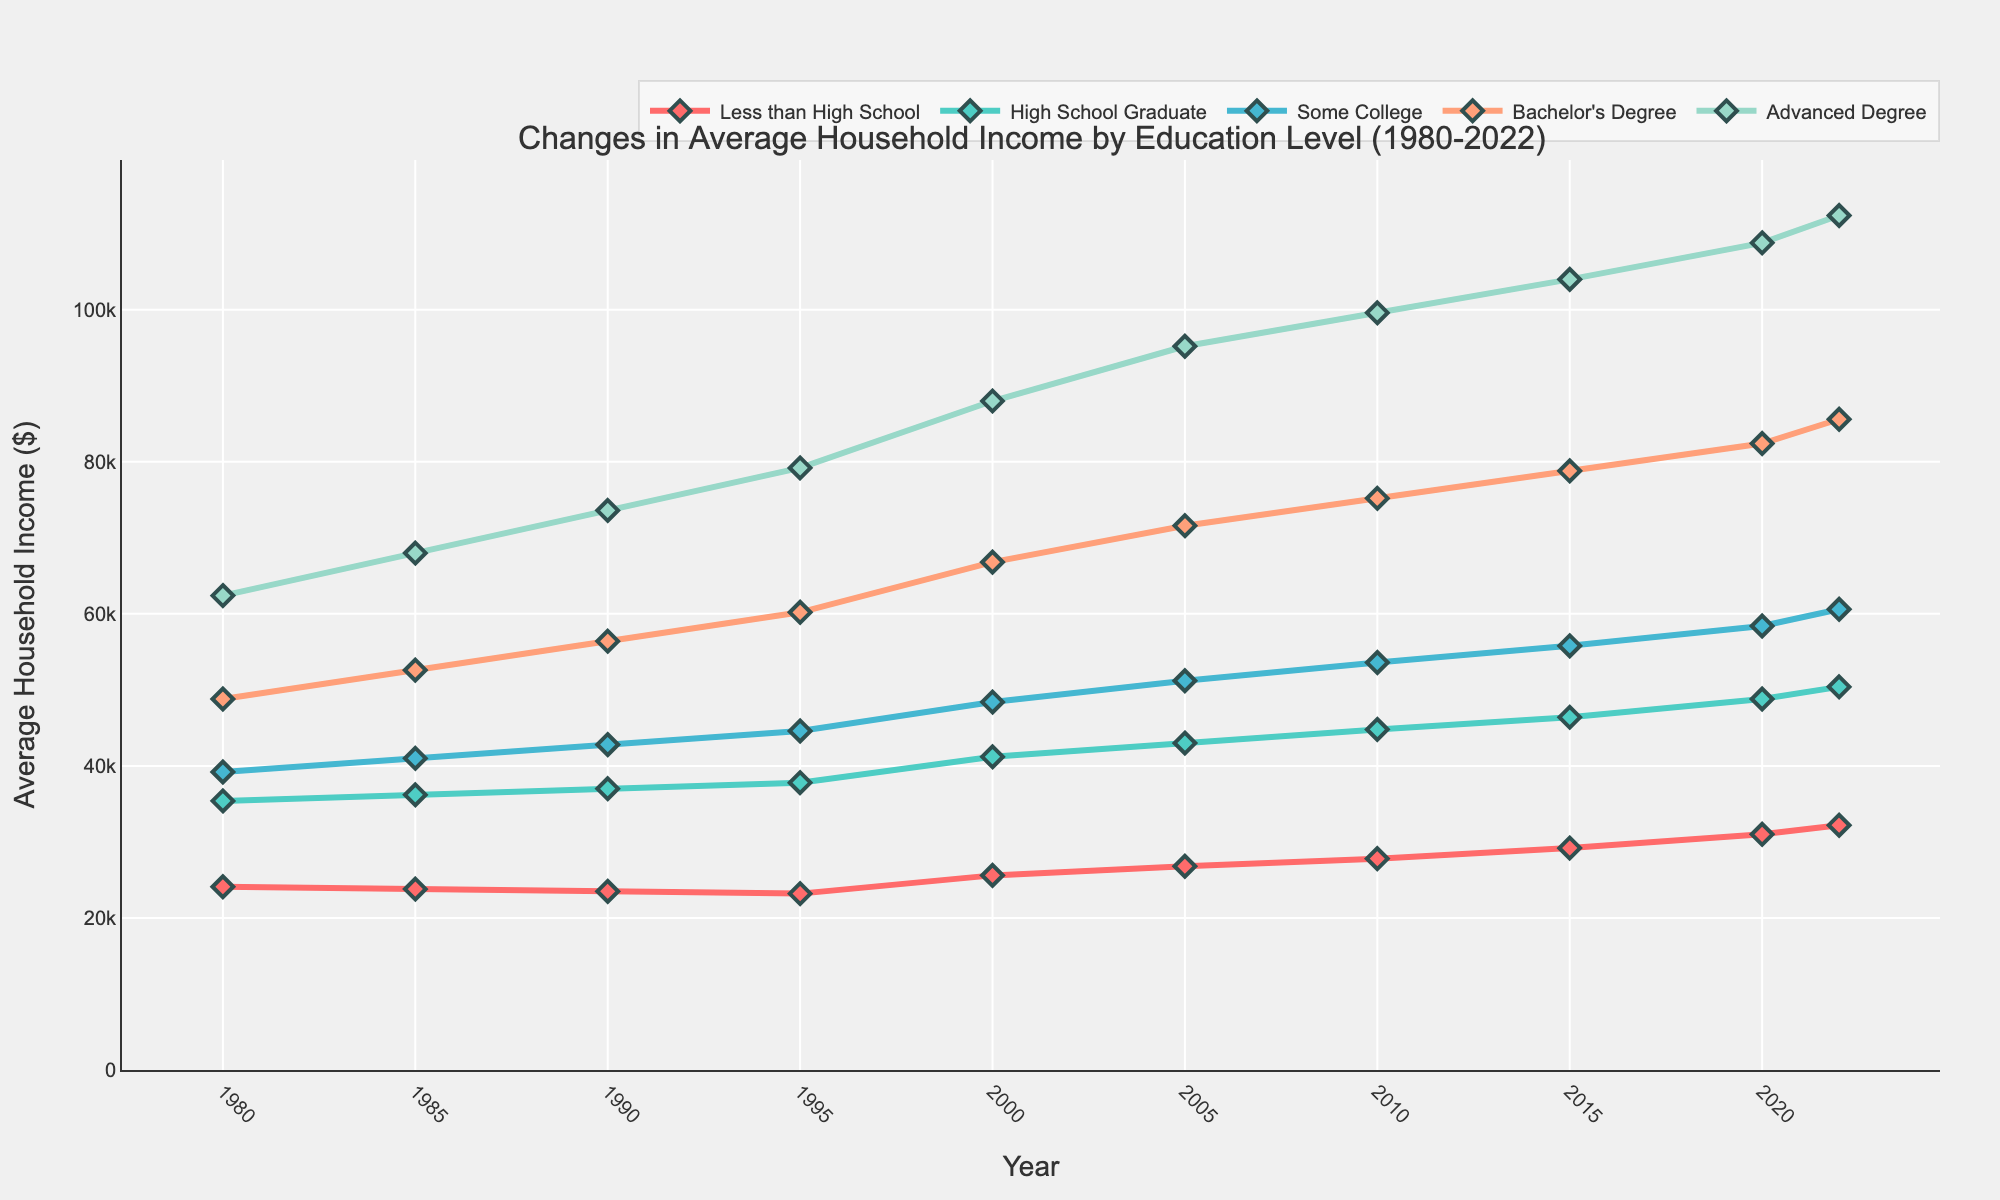What was the average household income for households with a Bachelor's Degree in 2000? In the figure, locate the point representing the average household income for Bachelor's Degree in the year 2000. The point is at $66,800.
Answer: $66,800 Which education level showed the highest increase in average household income from 1980 to 2022? Compare the start and end points for each education level from 1980 to 2022. Calculate the differences: Less than High School: $32,200 - $24,100 = $8,100; High School Graduate: $50,400 - $35,400 = $15,000; Some College: $60,600 - $39,200 = $21,400; Bachelor's Degree: $85,600 - $48,800 = $36,800; Advanced Degree: $112,400 - $62,400 = $50,000. The highest increase is for Advanced Degree.
Answer: Advanced Degree How did the average household income for those with Some College education change from 2000 to 2022? Identify the points on the figure for Some College in 2000 and 2022. The income in 2000 is $48,400, and the income in 2022 is $60,600. Calculate the difference: $60,600 - $48,400 = $12,200.
Answer: It increased by $12,200 Between which two consecutive years did households with a High School graduate level see the largest increase in average income? Observe the plot for the High School Graduate line and find where the steepest upward slope occurs between consecutive years. Calculate the differences: 1980-1985: $36,200 - $35,400 = $800; 1985-1990: $37,000 - $36,200 = $800; 1990-1995: $37,800 - $37,000 = $800; 1995-2000: $41,200 - $37,800 = $3,400; 2000-2005: $43,000 - $41,200 = $1,800; 2005-2010: $44,800 - $43,000 = $1,800; 2010-2015: $46,400 - $44,800 = $1,600; 2015-2020: $48,800 - $46,400 = $2,400; 2020-2022: $50,400 - $48,800 = $1,600. The largest increase is seen between 1995 and 2000.
Answer: 1995 and 2000 Which educational level has the least variability in income over the years? Observe the plot lines and note which one has the least fluctuation between points. The line for Less than High School is the smoothest with gradual changes.
Answer: Less than High School 